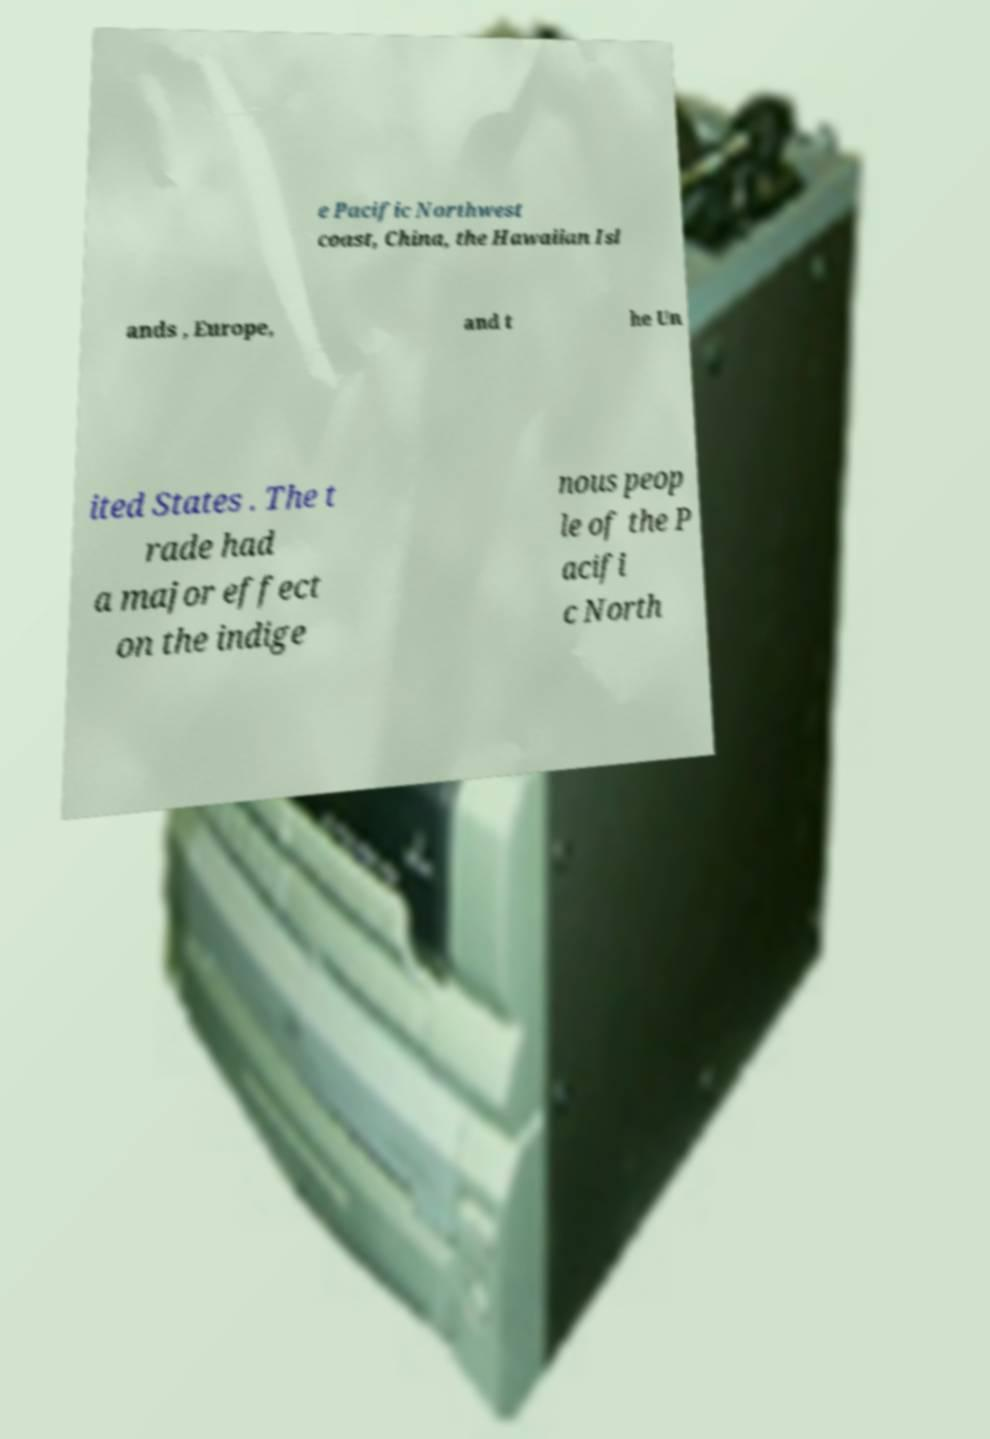Please read and relay the text visible in this image. What does it say? e Pacific Northwest coast, China, the Hawaiian Isl ands , Europe, and t he Un ited States . The t rade had a major effect on the indige nous peop le of the P acifi c North 